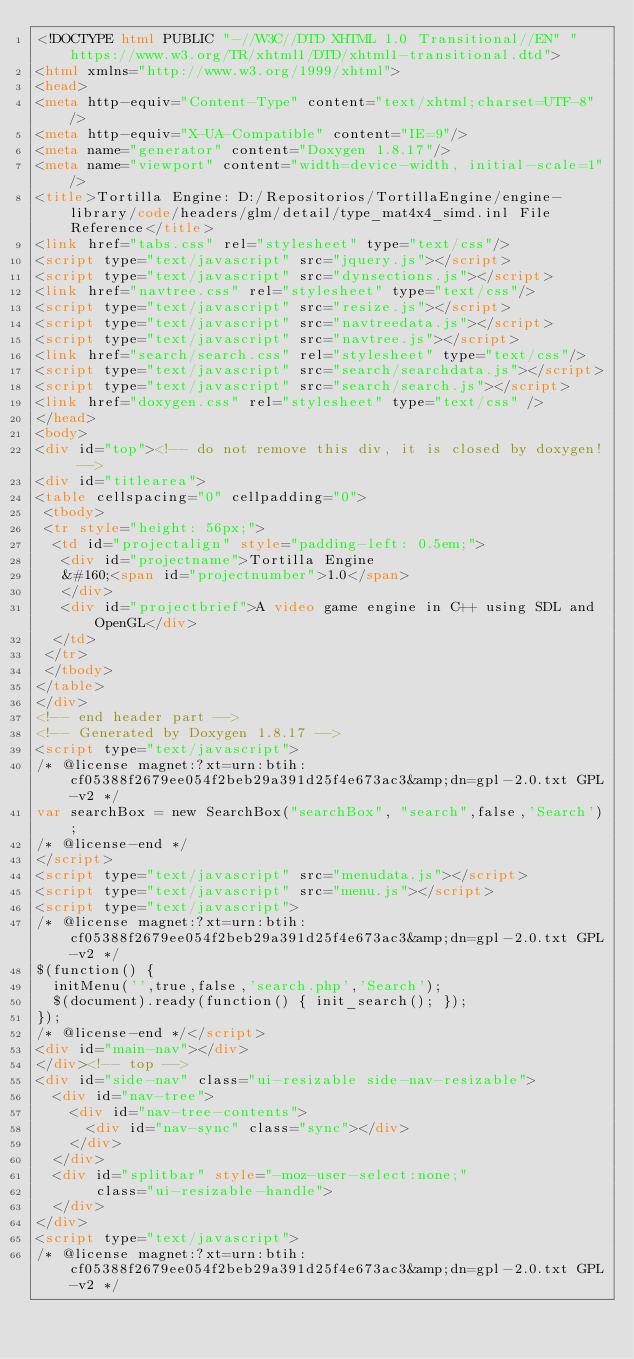Convert code to text. <code><loc_0><loc_0><loc_500><loc_500><_HTML_><!DOCTYPE html PUBLIC "-//W3C//DTD XHTML 1.0 Transitional//EN" "https://www.w3.org/TR/xhtml1/DTD/xhtml1-transitional.dtd">
<html xmlns="http://www.w3.org/1999/xhtml">
<head>
<meta http-equiv="Content-Type" content="text/xhtml;charset=UTF-8"/>
<meta http-equiv="X-UA-Compatible" content="IE=9"/>
<meta name="generator" content="Doxygen 1.8.17"/>
<meta name="viewport" content="width=device-width, initial-scale=1"/>
<title>Tortilla Engine: D:/Repositorios/TortillaEngine/engine-library/code/headers/glm/detail/type_mat4x4_simd.inl File Reference</title>
<link href="tabs.css" rel="stylesheet" type="text/css"/>
<script type="text/javascript" src="jquery.js"></script>
<script type="text/javascript" src="dynsections.js"></script>
<link href="navtree.css" rel="stylesheet" type="text/css"/>
<script type="text/javascript" src="resize.js"></script>
<script type="text/javascript" src="navtreedata.js"></script>
<script type="text/javascript" src="navtree.js"></script>
<link href="search/search.css" rel="stylesheet" type="text/css"/>
<script type="text/javascript" src="search/searchdata.js"></script>
<script type="text/javascript" src="search/search.js"></script>
<link href="doxygen.css" rel="stylesheet" type="text/css" />
</head>
<body>
<div id="top"><!-- do not remove this div, it is closed by doxygen! -->
<div id="titlearea">
<table cellspacing="0" cellpadding="0">
 <tbody>
 <tr style="height: 56px;">
  <td id="projectalign" style="padding-left: 0.5em;">
   <div id="projectname">Tortilla Engine
   &#160;<span id="projectnumber">1.0</span>
   </div>
   <div id="projectbrief">A video game engine in C++ using SDL and OpenGL</div>
  </td>
 </tr>
 </tbody>
</table>
</div>
<!-- end header part -->
<!-- Generated by Doxygen 1.8.17 -->
<script type="text/javascript">
/* @license magnet:?xt=urn:btih:cf05388f2679ee054f2beb29a391d25f4e673ac3&amp;dn=gpl-2.0.txt GPL-v2 */
var searchBox = new SearchBox("searchBox", "search",false,'Search');
/* @license-end */
</script>
<script type="text/javascript" src="menudata.js"></script>
<script type="text/javascript" src="menu.js"></script>
<script type="text/javascript">
/* @license magnet:?xt=urn:btih:cf05388f2679ee054f2beb29a391d25f4e673ac3&amp;dn=gpl-2.0.txt GPL-v2 */
$(function() {
  initMenu('',true,false,'search.php','Search');
  $(document).ready(function() { init_search(); });
});
/* @license-end */</script>
<div id="main-nav"></div>
</div><!-- top -->
<div id="side-nav" class="ui-resizable side-nav-resizable">
  <div id="nav-tree">
    <div id="nav-tree-contents">
      <div id="nav-sync" class="sync"></div>
    </div>
  </div>
  <div id="splitbar" style="-moz-user-select:none;" 
       class="ui-resizable-handle">
  </div>
</div>
<script type="text/javascript">
/* @license magnet:?xt=urn:btih:cf05388f2679ee054f2beb29a391d25f4e673ac3&amp;dn=gpl-2.0.txt GPL-v2 */</code> 